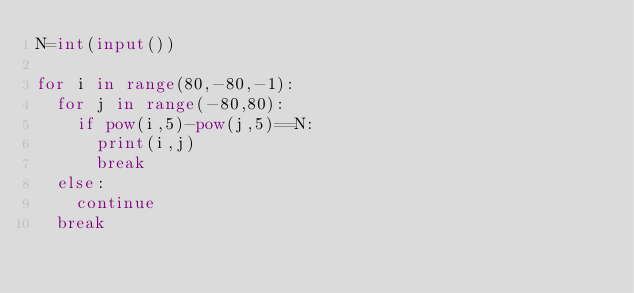Convert code to text. <code><loc_0><loc_0><loc_500><loc_500><_Python_>N=int(input())

for i in range(80,-80,-1):
  for j in range(-80,80):
    if pow(i,5)-pow(j,5)==N:
      print(i,j)
      break
  else:
    continue
  break
</code> 